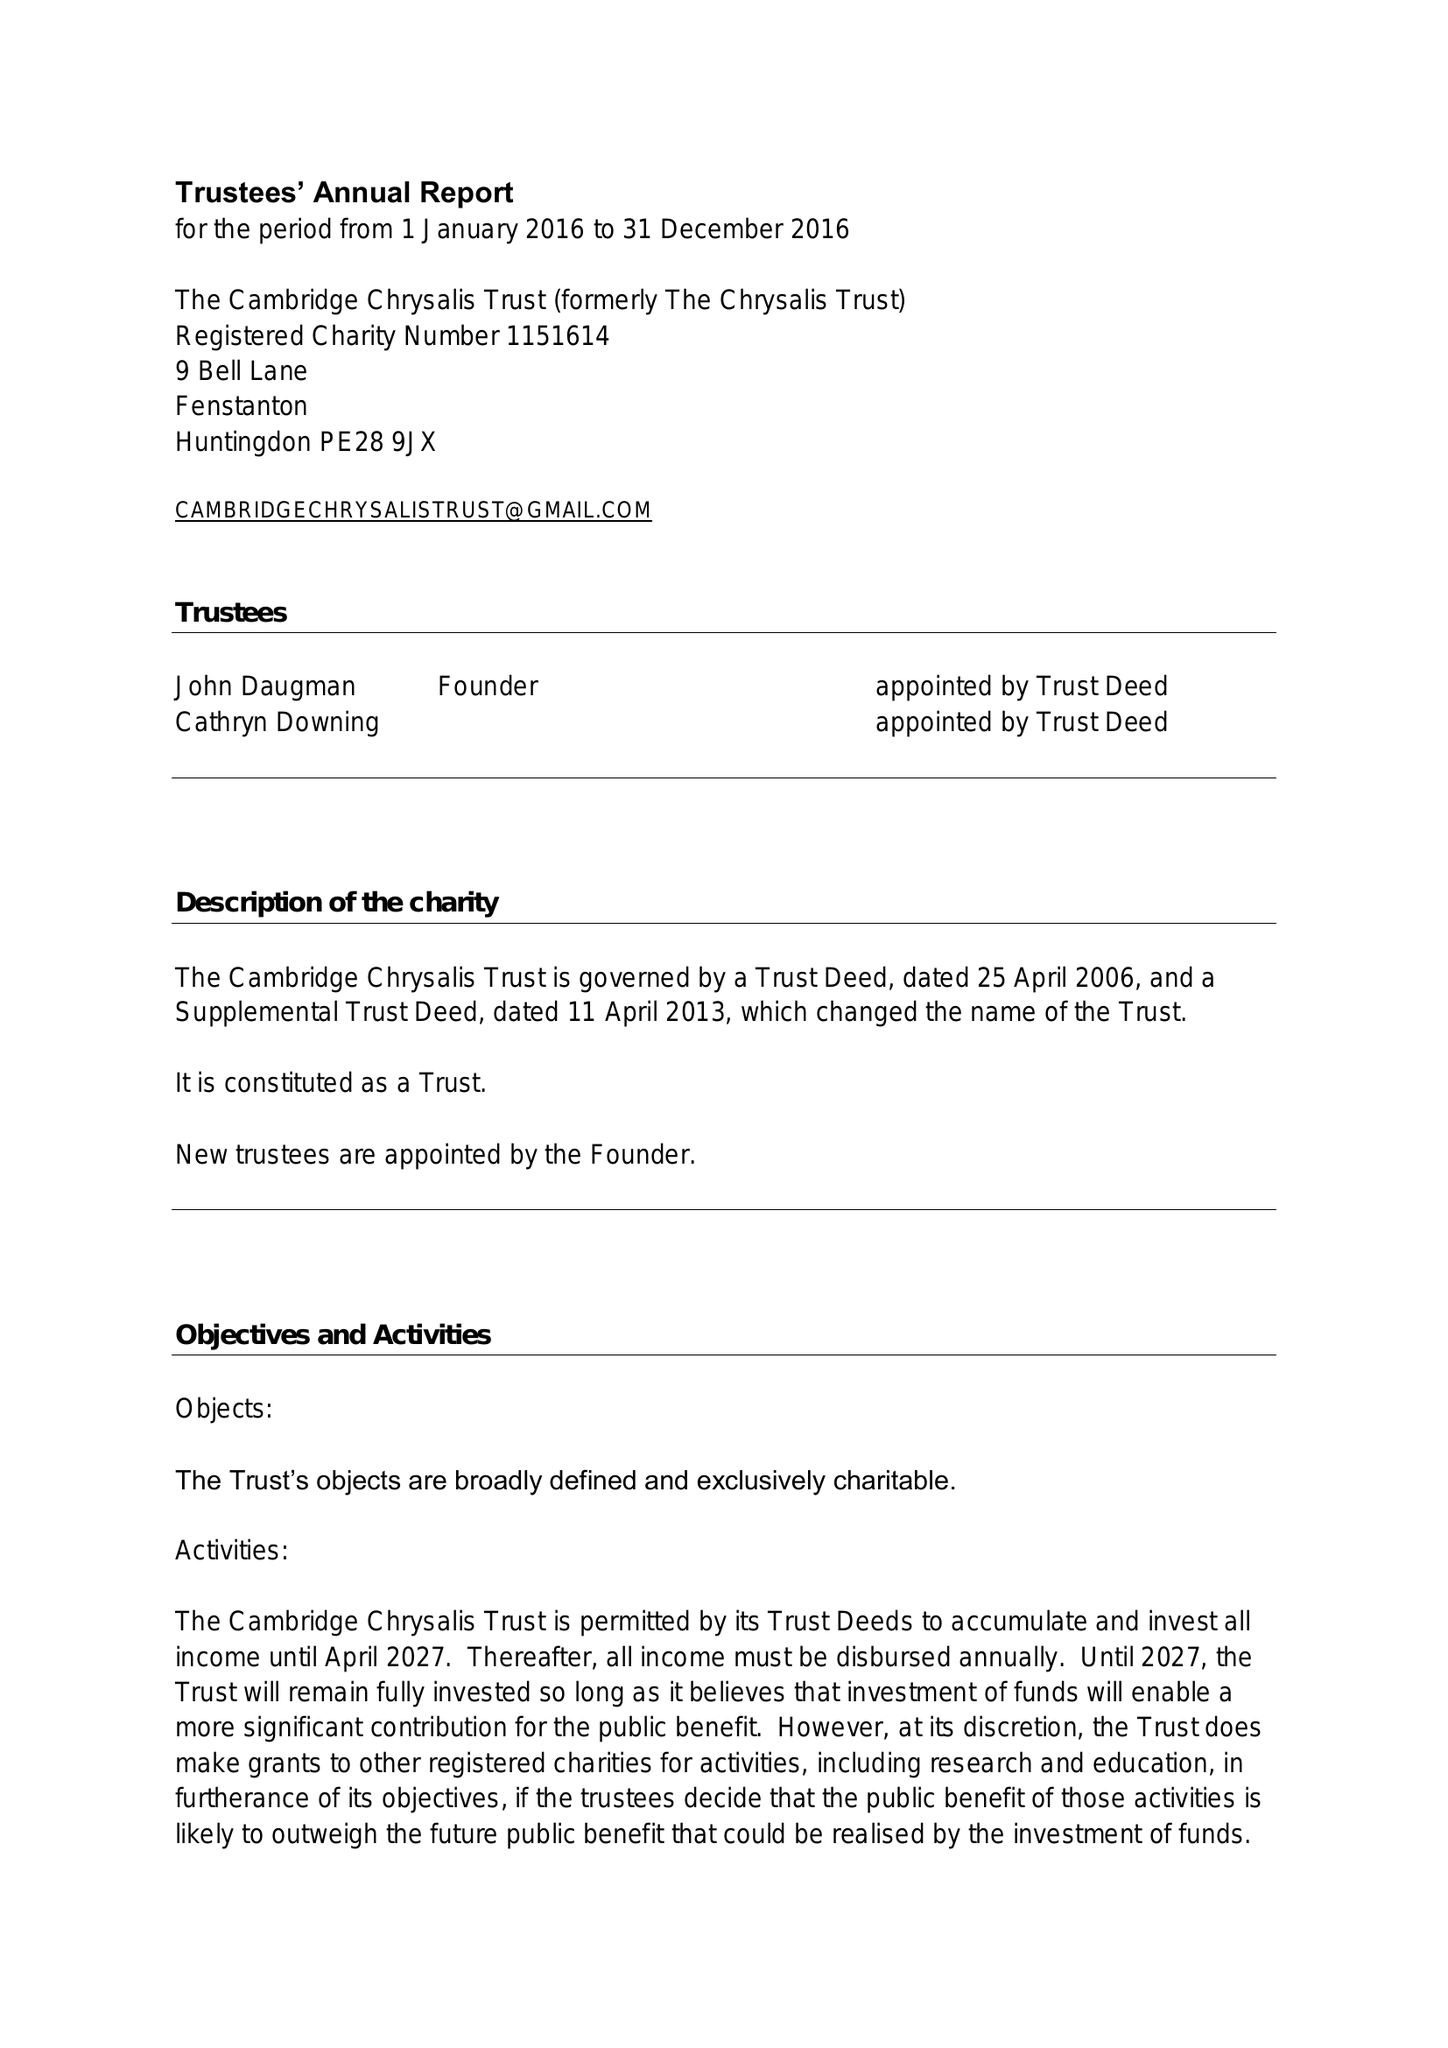What is the value for the address__postcode?
Answer the question using a single word or phrase. PE28 9JX 